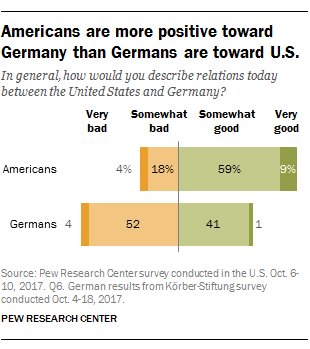Highlight a few significant elements in this photo. The difference between the highest and lowest percentage is 58%. The highest value in "Total" represents a somewhat good outcome. 